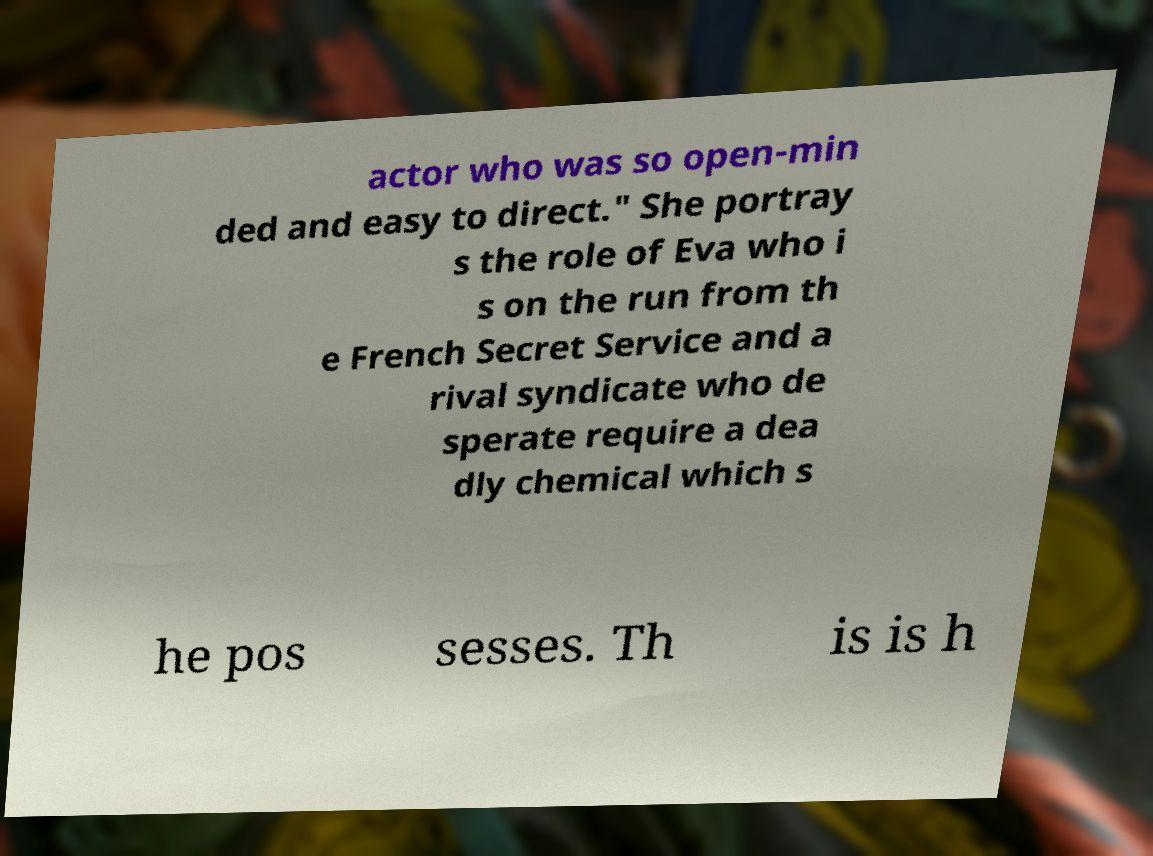I need the written content from this picture converted into text. Can you do that? actor who was so open-min ded and easy to direct." She portray s the role of Eva who i s on the run from th e French Secret Service and a rival syndicate who de sperate require a dea dly chemical which s he pos sesses. Th is is h 